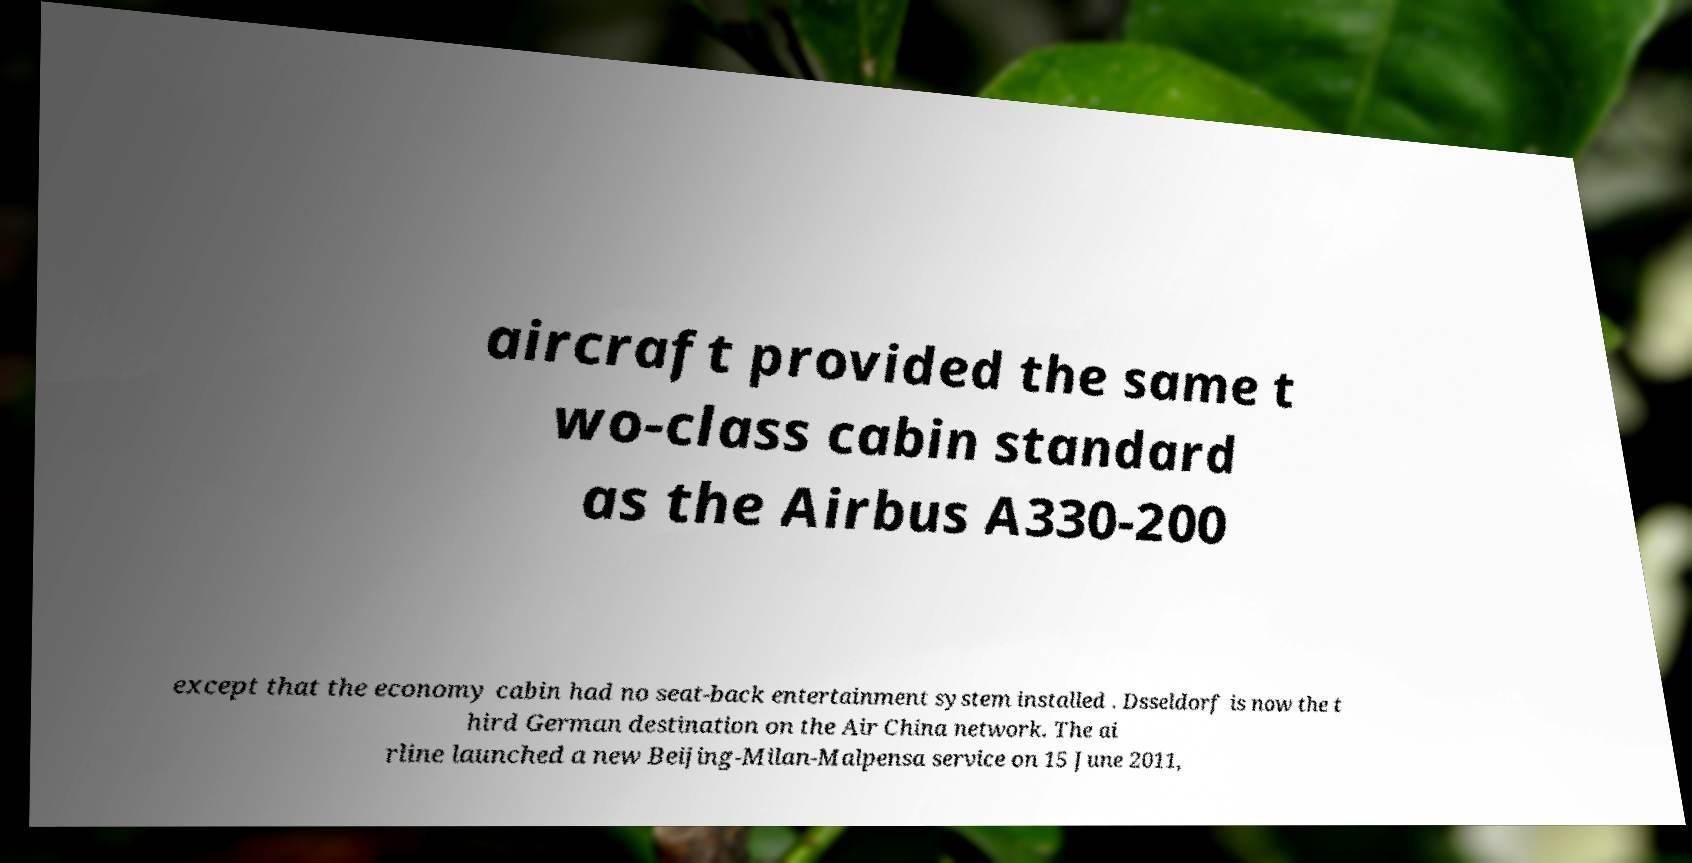Can you accurately transcribe the text from the provided image for me? aircraft provided the same t wo-class cabin standard as the Airbus A330-200 except that the economy cabin had no seat-back entertainment system installed . Dsseldorf is now the t hird German destination on the Air China network. The ai rline launched a new Beijing-Milan-Malpensa service on 15 June 2011, 